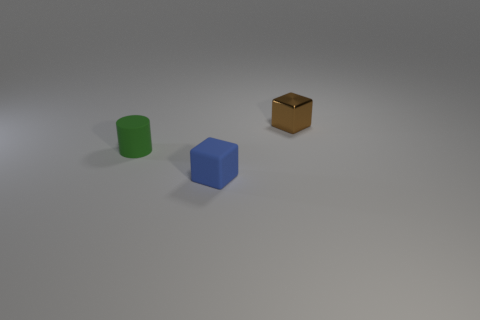There is a rubber thing in front of the green rubber thing behind the small matte cube; how many small metal things are in front of it?
Provide a short and direct response. 0. What is the material of the brown object that is the same size as the blue rubber cube?
Offer a terse response. Metal. How many tiny green rubber cylinders are behind the brown thing?
Provide a short and direct response. 0. Does the block that is in front of the tiny cylinder have the same material as the small thing that is left of the small blue thing?
Ensure brevity in your answer.  Yes. The thing on the right side of the tiny cube in front of the small thing that is right of the small blue cube is what shape?
Ensure brevity in your answer.  Cube. What is the shape of the tiny brown metal thing?
Give a very brief answer. Cube. What is the shape of the blue object that is the same size as the brown shiny object?
Make the answer very short. Cube. How many other things are there of the same color as the tiny matte cube?
Your response must be concise. 0. There is a object behind the rubber cylinder; is it the same shape as the matte thing behind the tiny blue rubber block?
Provide a short and direct response. No. What number of objects are either matte objects in front of the rubber cylinder or cubes to the left of the brown metallic cube?
Give a very brief answer. 1. 